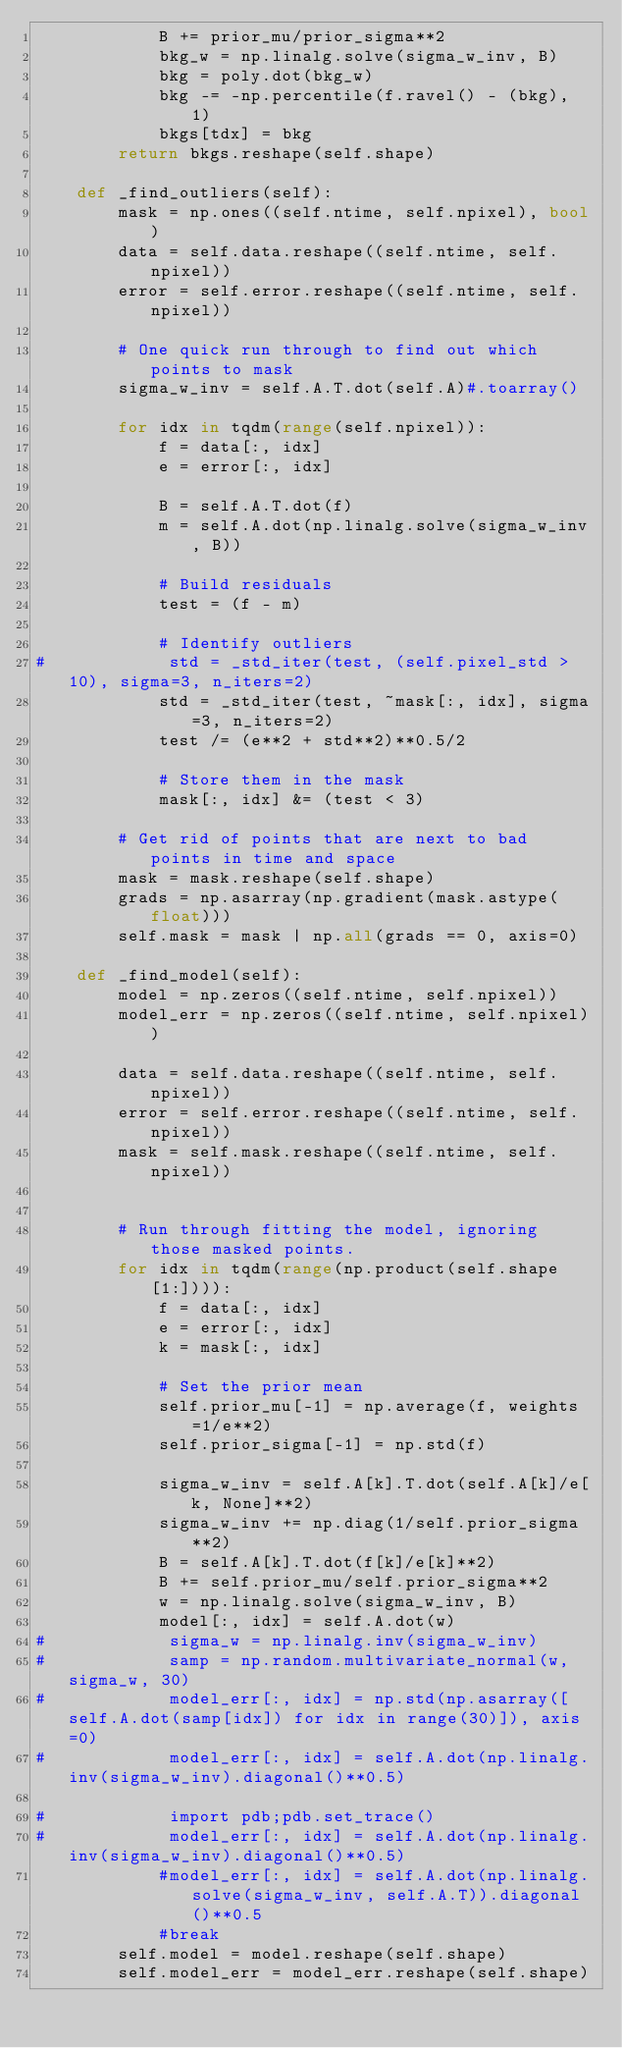Convert code to text. <code><loc_0><loc_0><loc_500><loc_500><_Python_>            B += prior_mu/prior_sigma**2
            bkg_w = np.linalg.solve(sigma_w_inv, B)
            bkg = poly.dot(bkg_w)
            bkg -= -np.percentile(f.ravel() - (bkg), 1)
            bkgs[tdx] = bkg
        return bkgs.reshape(self.shape)

    def _find_outliers(self):
        mask = np.ones((self.ntime, self.npixel), bool)
        data = self.data.reshape((self.ntime, self.npixel))
        error = self.error.reshape((self.ntime, self.npixel))

        # One quick run through to find out which points to mask
        sigma_w_inv = self.A.T.dot(self.A)#.toarray()

        for idx in tqdm(range(self.npixel)):
            f = data[:, idx]
            e = error[:, idx]

            B = self.A.T.dot(f)
            m = self.A.dot(np.linalg.solve(sigma_w_inv, B))

            # Build residuals
            test = (f - m)

            # Identify outliers
#            std = _std_iter(test, (self.pixel_std > 10), sigma=3, n_iters=2)
            std = _std_iter(test, ~mask[:, idx], sigma=3, n_iters=2)
            test /= (e**2 + std**2)**0.5/2

            # Store them in the mask
            mask[:, idx] &= (test < 3)

        # Get rid of points that are next to bad points in time and space
        mask = mask.reshape(self.shape)
        grads = np.asarray(np.gradient(mask.astype(float)))
        self.mask = mask | np.all(grads == 0, axis=0)

    def _find_model(self):
        model = np.zeros((self.ntime, self.npixel))
        model_err = np.zeros((self.ntime, self.npixel))

        data = self.data.reshape((self.ntime, self.npixel))
        error = self.error.reshape((self.ntime, self.npixel))
        mask = self.mask.reshape((self.ntime, self.npixel))


        # Run through fitting the model, ignoring those masked points.
        for idx in tqdm(range(np.product(self.shape[1:]))):
            f = data[:, idx]
            e = error[:, idx]
            k = mask[:, idx]

            # Set the prior mean
            self.prior_mu[-1] = np.average(f, weights=1/e**2)
            self.prior_sigma[-1] = np.std(f)

            sigma_w_inv = self.A[k].T.dot(self.A[k]/e[k, None]**2)
            sigma_w_inv += np.diag(1/self.prior_sigma**2)
            B = self.A[k].T.dot(f[k]/e[k]**2)
            B += self.prior_mu/self.prior_sigma**2
            w = np.linalg.solve(sigma_w_inv, B)
            model[:, idx] = self.A.dot(w)
#            sigma_w = np.linalg.inv(sigma_w_inv)
#            samp = np.random.multivariate_normal(w, sigma_w, 30)
#            model_err[:, idx] = np.std(np.asarray([self.A.dot(samp[idx]) for idx in range(30)]), axis=0)
#            model_err[:, idx] = self.A.dot(np.linalg.inv(sigma_w_inv).diagonal()**0.5)

#            import pdb;pdb.set_trace()
#            model_err[:, idx] = self.A.dot(np.linalg.inv(sigma_w_inv).diagonal()**0.5)
            #model_err[:, idx] = self.A.dot(np.linalg.solve(sigma_w_inv, self.A.T)).diagonal()**0.5
            #break
        self.model = model.reshape(self.shape)
        self.model_err = model_err.reshape(self.shape)
</code> 